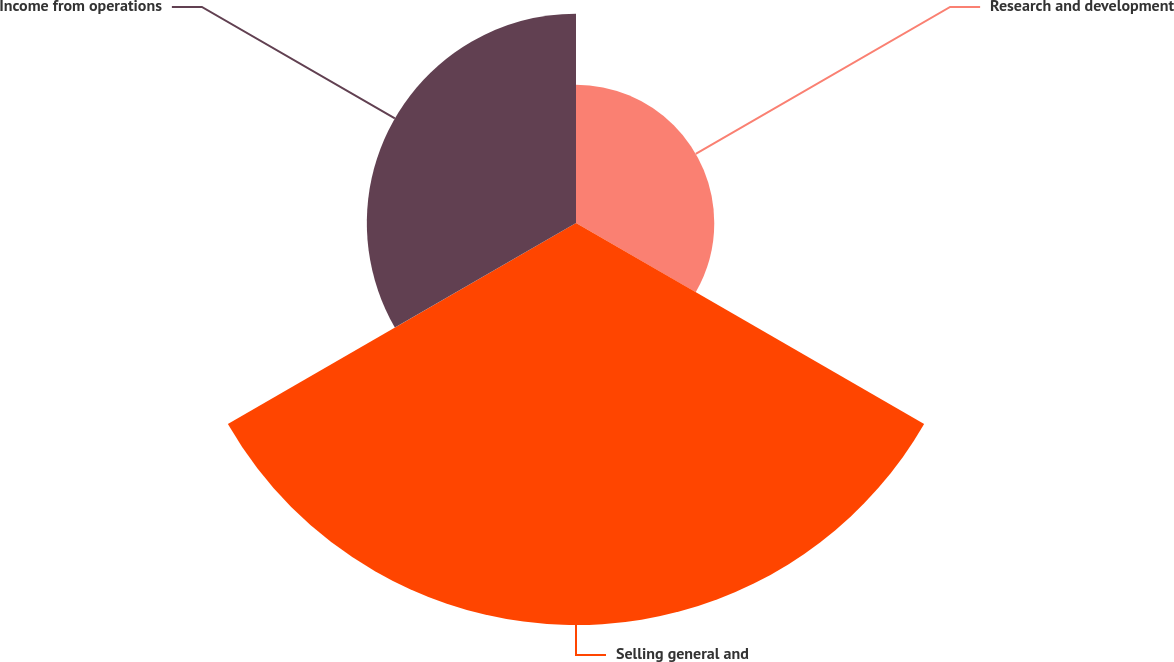Convert chart to OTSL. <chart><loc_0><loc_0><loc_500><loc_500><pie_chart><fcel>Research and development<fcel>Selling general and<fcel>Income from operations<nl><fcel>18.45%<fcel>53.64%<fcel>27.91%<nl></chart> 